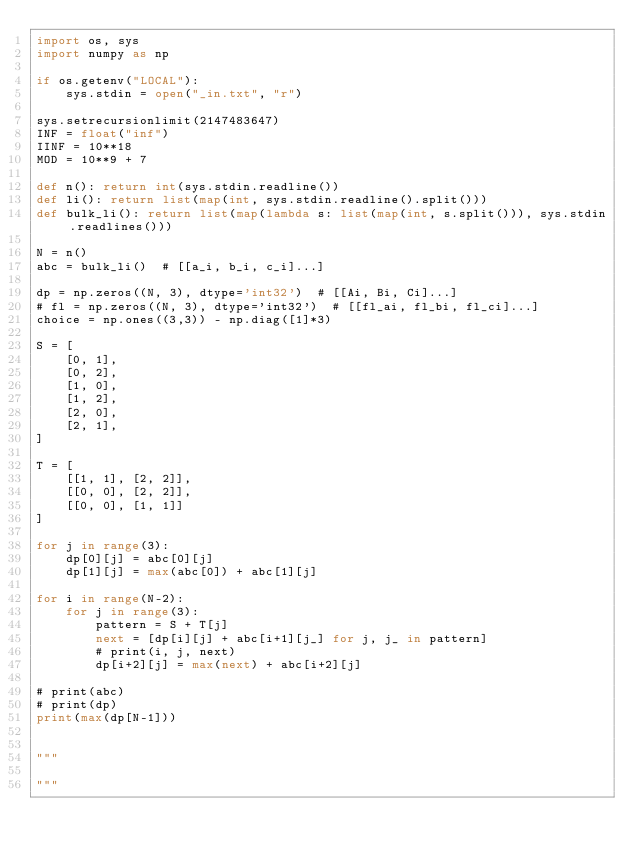Convert code to text. <code><loc_0><loc_0><loc_500><loc_500><_Python_>import os, sys
import numpy as np

if os.getenv("LOCAL"):
    sys.stdin = open("_in.txt", "r")
 
sys.setrecursionlimit(2147483647)
INF = float("inf")
IINF = 10**18
MOD = 10**9 + 7

def n(): return int(sys.stdin.readline())
def li(): return list(map(int, sys.stdin.readline().split()))
def bulk_li(): return list(map(lambda s: list(map(int, s.split())), sys.stdin.readlines()))

N = n()
abc = bulk_li()  # [[a_i, b_i, c_i]...]

dp = np.zeros((N, 3), dtype='int32')  # [[Ai, Bi, Ci]...]
# fl = np.zeros((N, 3), dtype='int32')  # [[fl_ai, fl_bi, fl_ci]...]
choice = np.ones((3,3)) - np.diag([1]*3)

S = [
    [0, 1],
    [0, 2],
    [1, 0],
    [1, 2],
    [2, 0],
    [2, 1],
]

T = [
    [[1, 1], [2, 2]],
    [[0, 0], [2, 2]],
    [[0, 0], [1, 1]]
]

for j in range(3):
    dp[0][j] = abc[0][j]
    dp[1][j] = max(abc[0]) + abc[1][j]

for i in range(N-2):
    for j in range(3):
        pattern = S + T[j]
        next = [dp[i][j] + abc[i+1][j_] for j, j_ in pattern]
        # print(i, j, next)
        dp[i+2][j] = max(next) + abc[i+2][j]

# print(abc)
# print(dp)
print(max(dp[N-1]))


"""

"""
</code> 